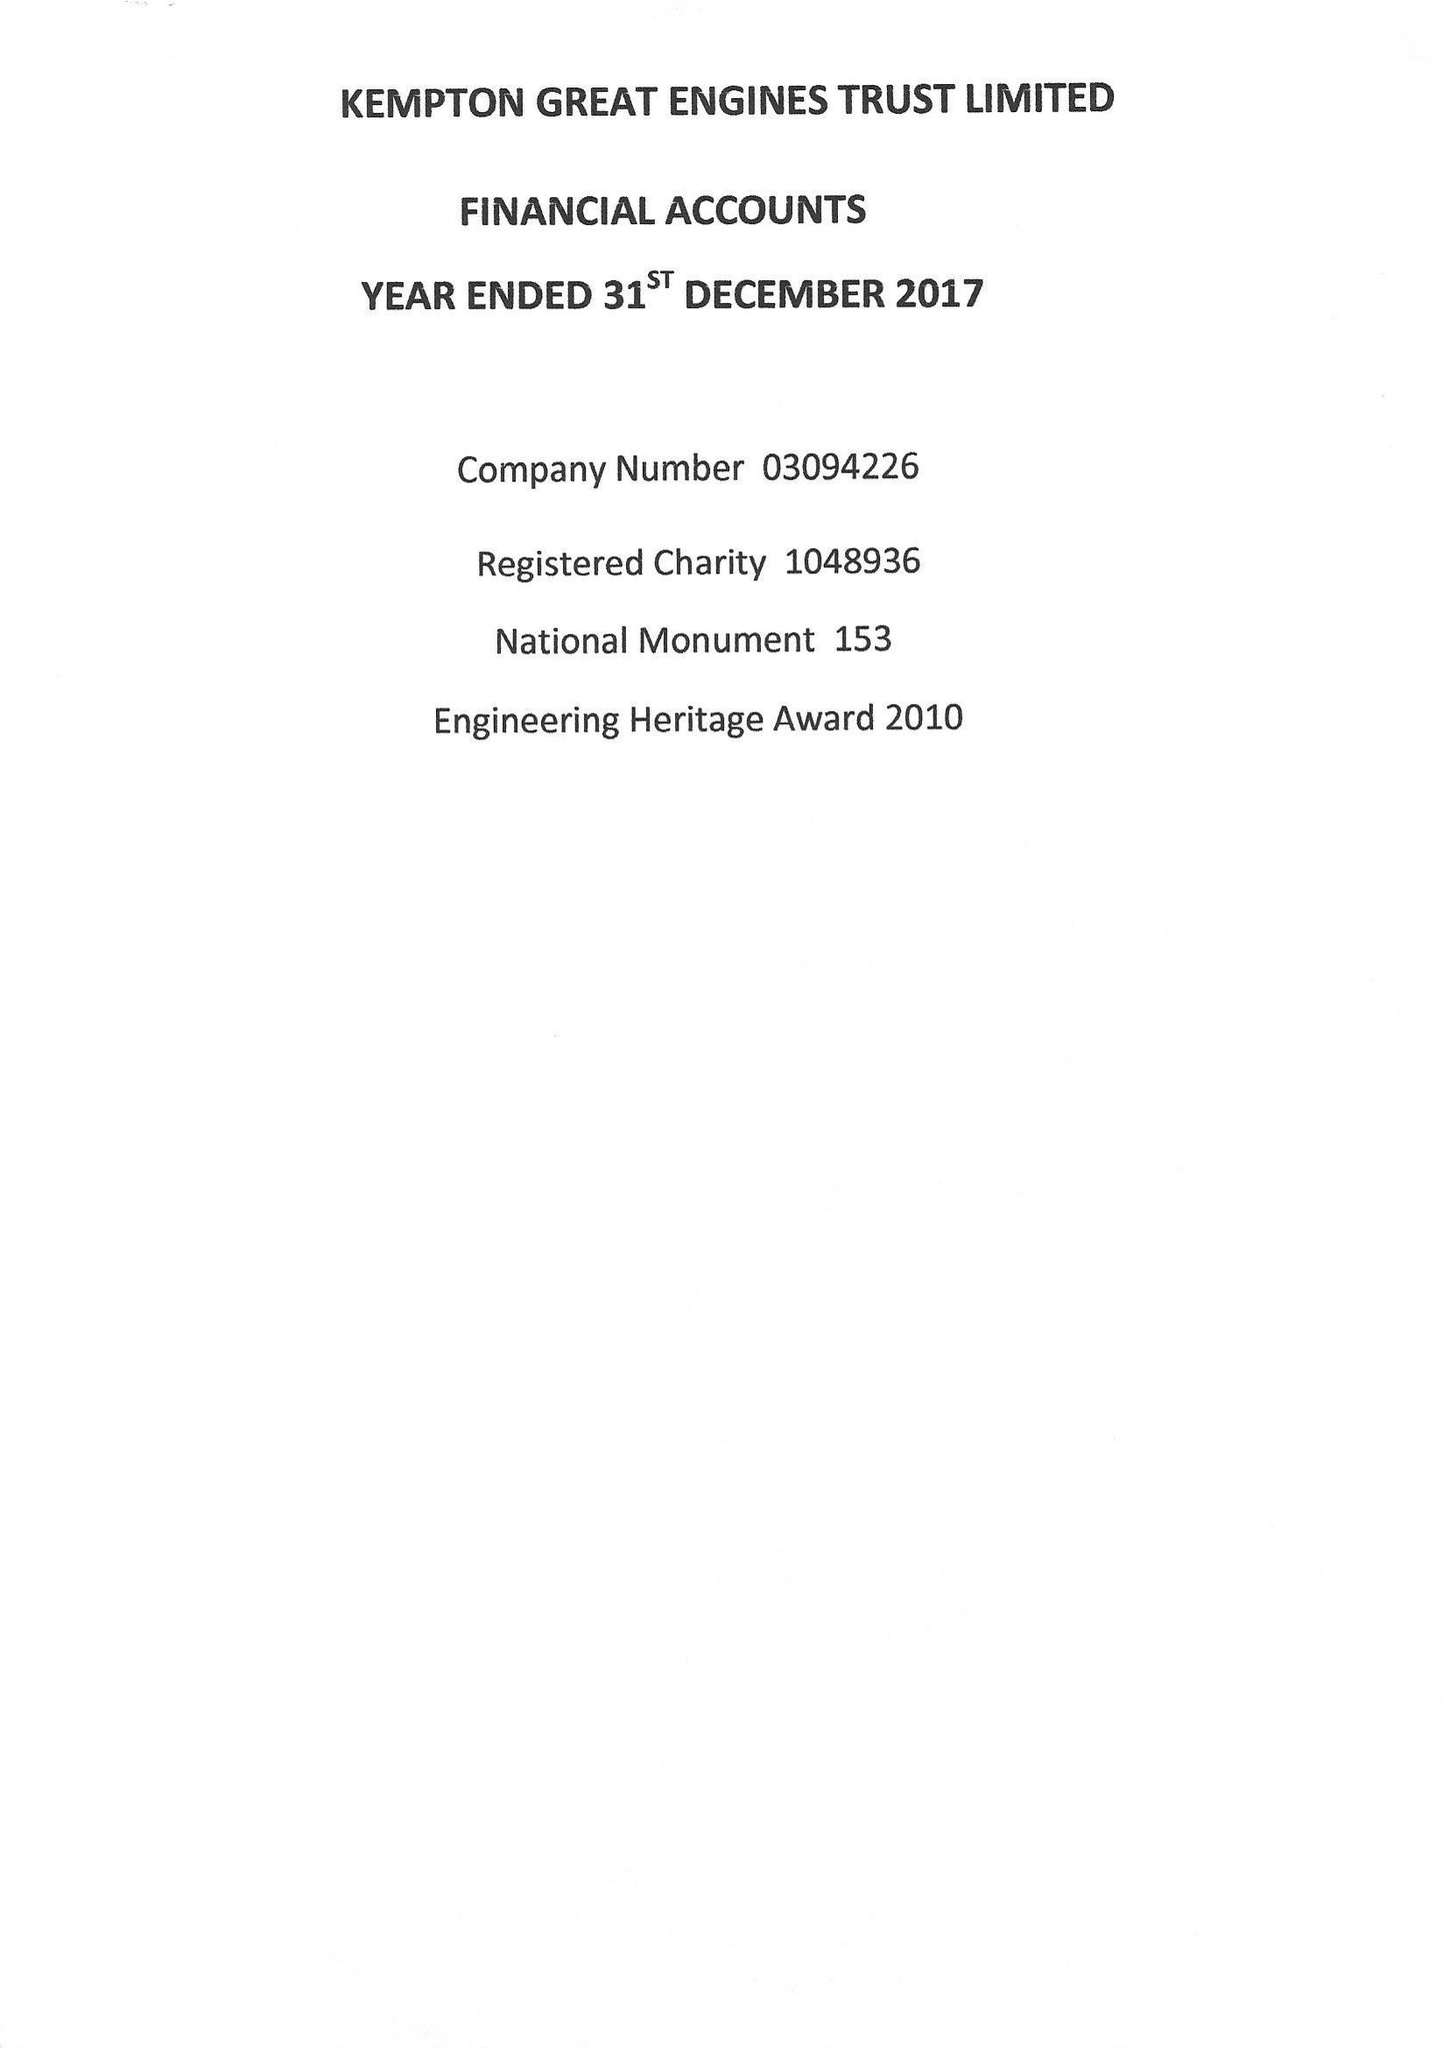What is the value for the address__street_line?
Answer the question using a single word or phrase. SNAKEY LANE 